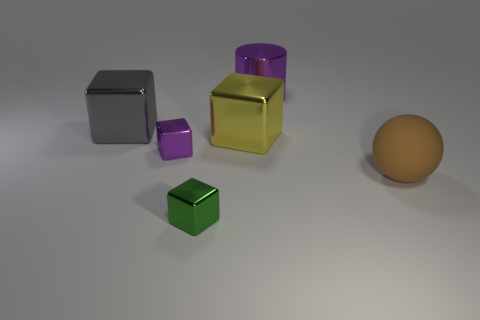Is there anything else that has the same shape as the matte object?
Provide a succinct answer. No. Are there any small gray metallic objects?
Your response must be concise. No. There is a purple shiny thing that is in front of the gray metallic block; does it have the same size as the purple thing that is behind the big gray metallic cube?
Keep it short and to the point. No. What material is the object that is right of the large yellow object and in front of the purple block?
Offer a very short reply. Rubber. There is a gray metallic block; what number of big metal things are behind it?
Ensure brevity in your answer.  1. There is another small cube that is the same material as the green cube; what is its color?
Provide a succinct answer. Purple. Do the gray thing and the big brown matte thing have the same shape?
Offer a very short reply. No. What number of metallic objects are behind the green object and to the left of the purple cylinder?
Your answer should be compact. 3. How many matte objects are either purple objects or big yellow cubes?
Provide a short and direct response. 0. There is a cylinder left of the large brown sphere on the right side of the big purple shiny object; what is its size?
Offer a terse response. Large. 